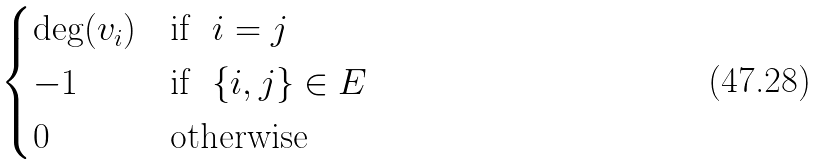Convert formula to latex. <formula><loc_0><loc_0><loc_500><loc_500>\begin{cases} \deg ( v _ { i } ) & \text {if \ } i = j \\ - 1 & \text {if \ } \{ i , j \} \in E \\ 0 & \text {otherwise} \end{cases}</formula> 